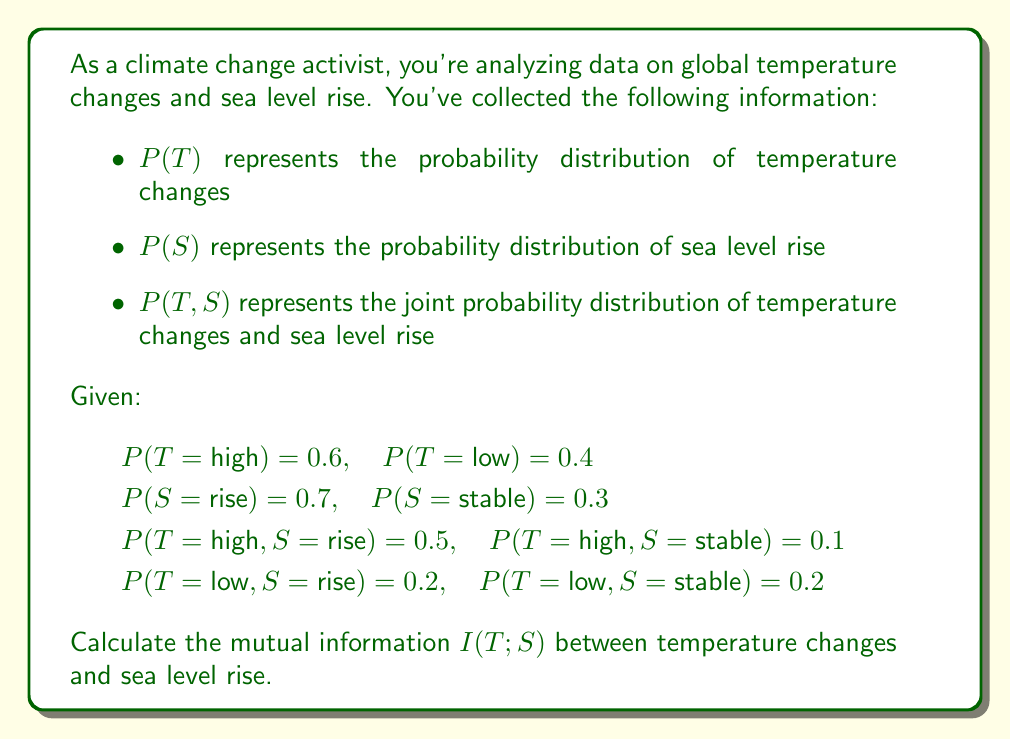Help me with this question. To calculate the mutual information $I(T;S)$, we'll use the formula:

$$I(T;S) = \sum_{t \in T} \sum_{s \in S} P(t,s) \log_2 \frac{P(t,s)}{P(t)P(s)}$$

Let's break this down step-by-step:

1) First, we need to calculate $P(t)P(s)$ for each combination:

   $P(T=high)P(S=rise) = 0.6 \times 0.7 = 0.42$
   $P(T=high)P(S=stable) = 0.6 \times 0.3 = 0.18$
   $P(T=low)P(S=rise) = 0.4 \times 0.7 = 0.28$
   $P(T=low)P(S=stable) = 0.4 \times 0.3 = 0.12$

2) Now, we can calculate each term in the sum:

   For $T=high, S=rise$:
   $0.5 \log_2 \frac{0.5}{0.42} = 0.5 \log_2 1.19 = 0.5 \times 0.25 = 0.125$

   For $T=high, S=stable$:
   $0.1 \log_2 \frac{0.1}{0.18} = 0.1 \log_2 0.56 = 0.1 \times (-0.84) = -0.084$

   For $T=low, S=rise$:
   $0.2 \log_2 \frac{0.2}{0.28} = 0.2 \log_2 0.71 = 0.2 \times (-0.49) = -0.098$

   For $T=low, S=stable$:
   $0.2 \log_2 \frac{0.2}{0.12} = 0.2 \log_2 1.67 = 0.2 \times 0.74 = 0.148$

3) Sum all these terms:

   $I(T;S) = 0.125 + (-0.084) + (-0.098) + 0.148 = 0.091$ bits

This result indicates a small but positive mutual information between temperature changes and sea level rise, suggesting there is some dependency between these variables.
Answer: $I(T;S) = 0.091$ bits 